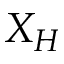Convert formula to latex. <formula><loc_0><loc_0><loc_500><loc_500>X _ { H }</formula> 